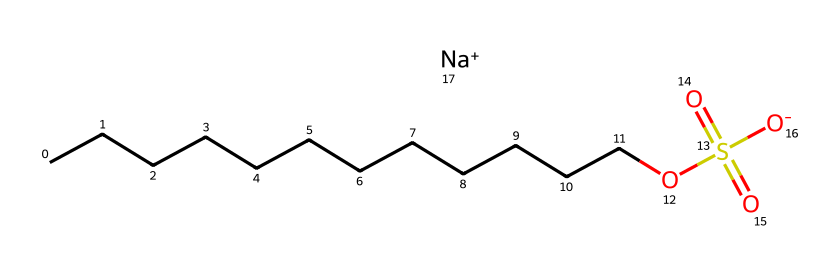what is the common name of this chemical? The chemical structure represents sodium dodecyl sulfate, which is a well-known surfactant used in cleaning products. The "sodium" and "dodecyl" parts of its name are evident in its structure, with the long carbon chain denoting "dodecyl."
Answer: sodium dodecyl sulfate how many carbon atoms are in the chain? The structure shows a long carbon chain (CCCCCCCCCCCC), which indicates there are 12 carbon atoms linked together in series. Each "C" in the chain represents one carbon atom.
Answer: 12 what functional group is represented in this chemical? The structure includes the sulfate group (OS(=O)(=O)[O-]), which is a recognizable functional group in surfactants. The presence of sulfur bonded to three oxygen atoms indicates a sulfate functional group.
Answer: sulfate how many oxygen atoms are present in this structure? By examining the chemical structure, specifically the sulfate part (OS(=O)(=O)[O-]), we can count a total of four oxygen atoms: three from the sulfate group and one attached to the sodium.
Answer: 4 what role does sodium play in the structure? Sodium is represented as [Na+] in the structure and serves as a counterion to balance the negatively charged sulfate group (O-). This positive sodium ion helps make the overall compound more soluble in water.
Answer: counterion what type of surfactant is sodium dodecyl sulfate classified as? Sodium dodecyl sulfate is classified as an anionic surfactant due to the presence of the negatively charged sulfate group. Anionic surfactants have a negative charge, which is key to their cleansing properties.
Answer: anionic 